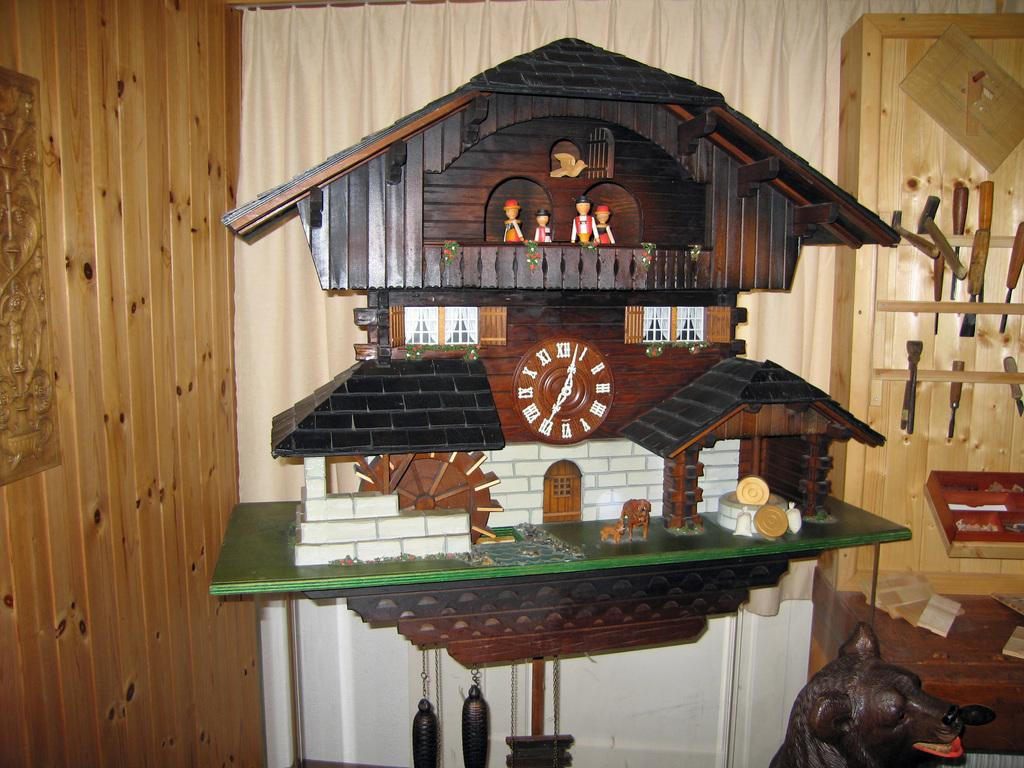Provide a one-sentence caption for the provided image. An elaborate coo-coo clock with the time showing 7:02. 